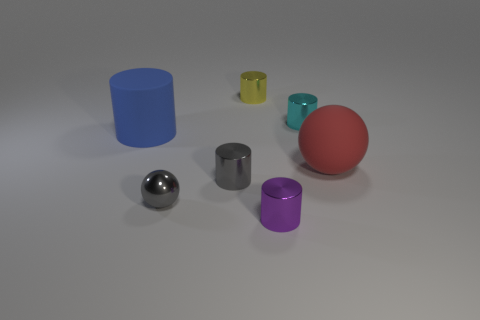Subtract all blue cylinders. How many cylinders are left? 4 Subtract 4 cylinders. How many cylinders are left? 1 Add 1 large blue matte objects. How many objects exist? 8 Subtract all cyan cylinders. How many cylinders are left? 4 Subtract all cylinders. How many objects are left? 2 Subtract 0 gray cubes. How many objects are left? 7 Subtract all brown cylinders. Subtract all yellow spheres. How many cylinders are left? 5 Subtract all large cyan rubber spheres. Subtract all big blue matte cylinders. How many objects are left? 6 Add 6 gray metal balls. How many gray metal balls are left? 7 Add 2 small gray metal objects. How many small gray metal objects exist? 4 